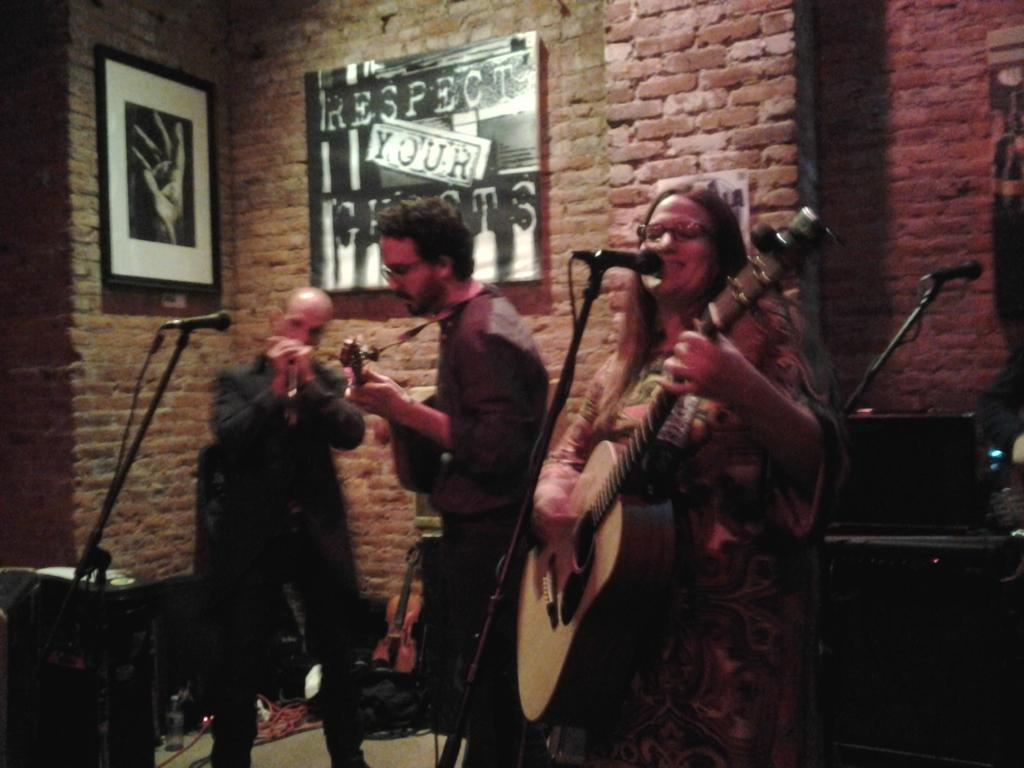How many people are in the image? There are three persons in the image. What are the persons doing in the image? They are playing music and singing. What can be seen in front of the persons? They are in front of a microphone. What is visible in the background of the image? There is a brick wall in the background of the image. What type of cream can be seen on the stage in the image? There is no stage or cream present in the image. Can you describe the cemetery visible in the background of the image? There is no cemetery visible in the background of the image; it features a brick wall. 